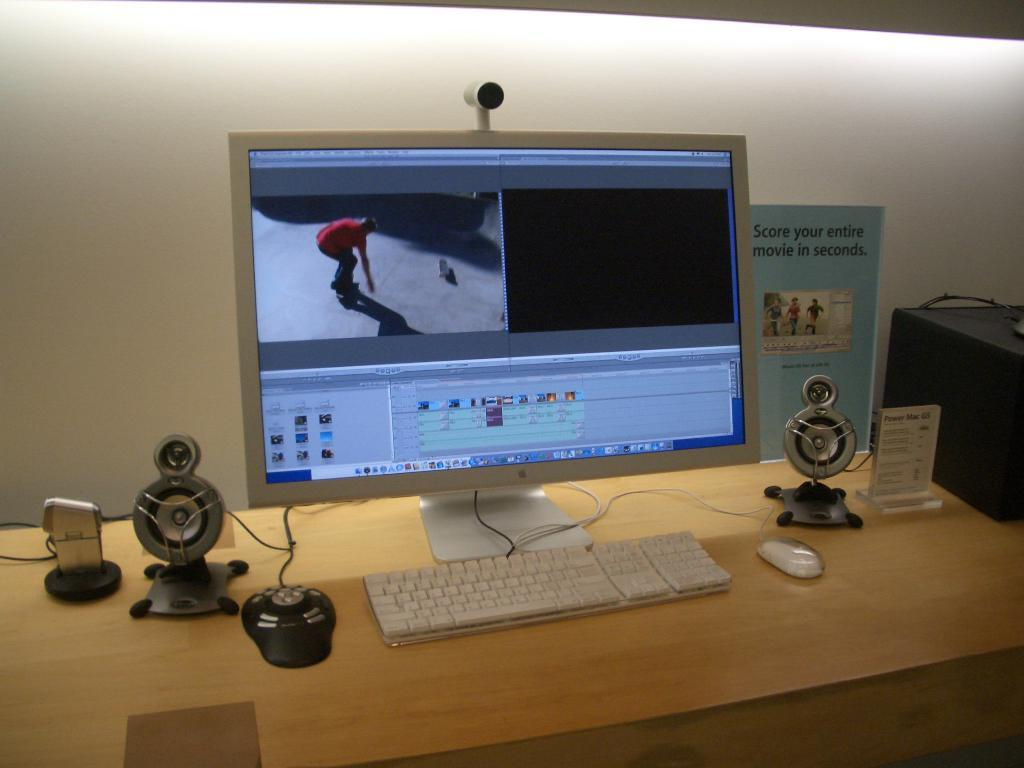Provide a one-sentence caption for the provided image. A desk with a Mac computer monitor and a flyer that says Score your entire movie in seconds. 